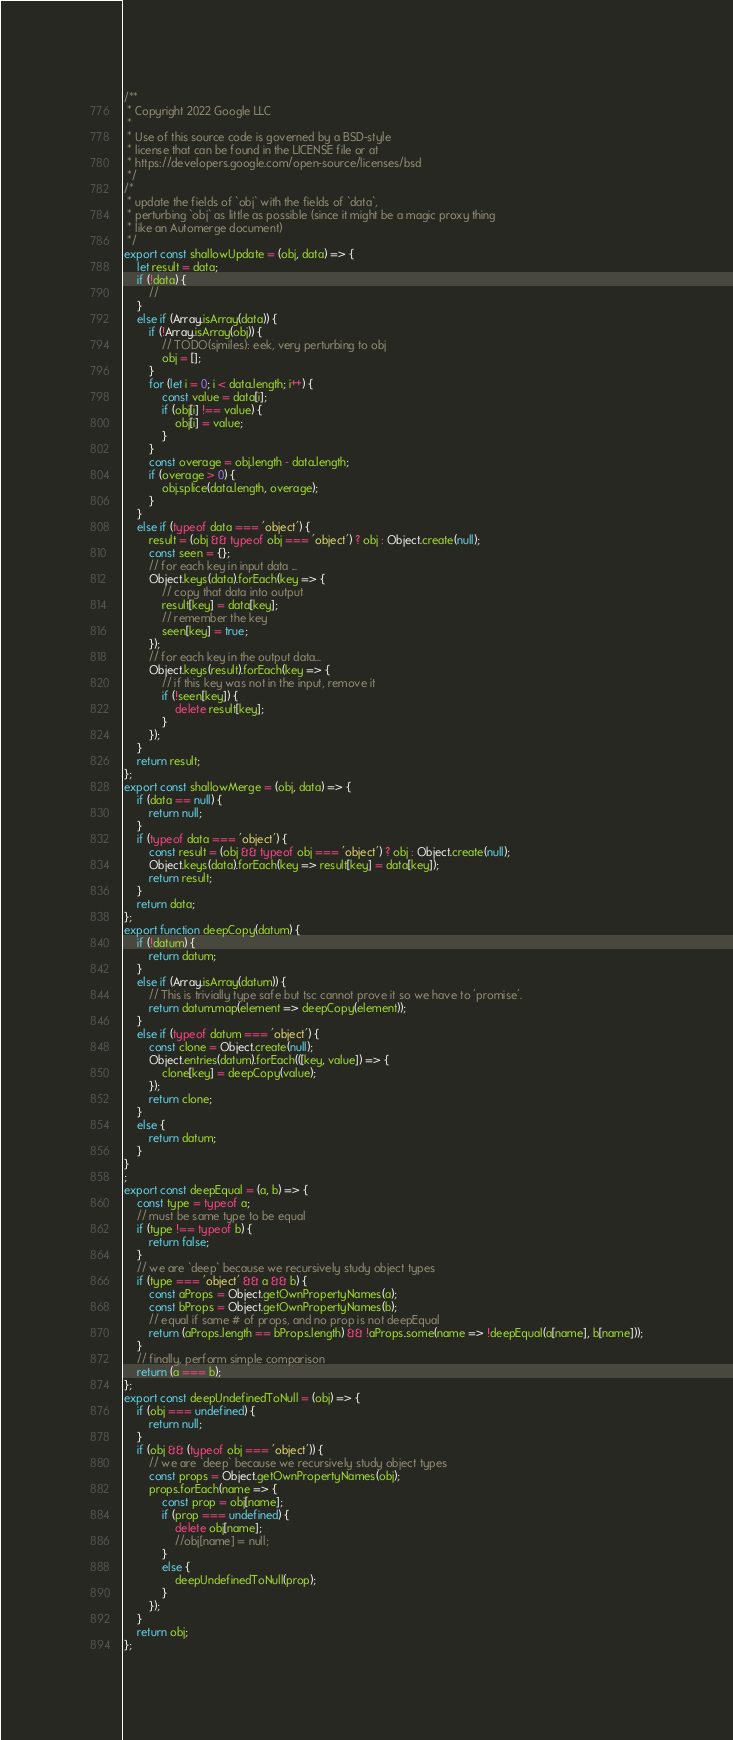Convert code to text. <code><loc_0><loc_0><loc_500><loc_500><_JavaScript_>/**
 * Copyright 2022 Google LLC
 *
 * Use of this source code is governed by a BSD-style
 * license that can be found in the LICENSE file or at
 * https://developers.google.com/open-source/licenses/bsd
 */
/*
 * update the fields of `obj` with the fields of `data`,
 * perturbing `obj` as little as possible (since it might be a magic proxy thing
 * like an Automerge document)
 */
export const shallowUpdate = (obj, data) => {
    let result = data;
    if (!data) {
        //
    }
    else if (Array.isArray(data)) {
        if (!Array.isArray(obj)) {
            // TODO(sjmiles): eek, very perturbing to obj
            obj = [];
        }
        for (let i = 0; i < data.length; i++) {
            const value = data[i];
            if (obj[i] !== value) {
                obj[i] = value;
            }
        }
        const overage = obj.length - data.length;
        if (overage > 0) {
            obj.splice(data.length, overage);
        }
    }
    else if (typeof data === 'object') {
        result = (obj && typeof obj === 'object') ? obj : Object.create(null);
        const seen = {};
        // for each key in input data ...
        Object.keys(data).forEach(key => {
            // copy that data into output
            result[key] = data[key];
            // remember the key
            seen[key] = true;
        });
        // for each key in the output data...
        Object.keys(result).forEach(key => {
            // if this key was not in the input, remove it
            if (!seen[key]) {
                delete result[key];
            }
        });
    }
    return result;
};
export const shallowMerge = (obj, data) => {
    if (data == null) {
        return null;
    }
    if (typeof data === 'object') {
        const result = (obj && typeof obj === 'object') ? obj : Object.create(null);
        Object.keys(data).forEach(key => result[key] = data[key]);
        return result;
    }
    return data;
};
export function deepCopy(datum) {
    if (!datum) {
        return datum;
    }
    else if (Array.isArray(datum)) {
        // This is trivially type safe but tsc cannot prove it so we have to 'promise'.
        return datum.map(element => deepCopy(element));
    }
    else if (typeof datum === 'object') {
        const clone = Object.create(null);
        Object.entries(datum).forEach(([key, value]) => {
            clone[key] = deepCopy(value);
        });
        return clone;
    }
    else {
        return datum;
    }
}
;
export const deepEqual = (a, b) => {
    const type = typeof a;
    // must be same type to be equal
    if (type !== typeof b) {
        return false;
    }
    // we are `deep` because we recursively study object types
    if (type === 'object' && a && b) {
        const aProps = Object.getOwnPropertyNames(a);
        const bProps = Object.getOwnPropertyNames(b);
        // equal if same # of props, and no prop is not deepEqual
        return (aProps.length == bProps.length) && !aProps.some(name => !deepEqual(a[name], b[name]));
    }
    // finally, perform simple comparison
    return (a === b);
};
export const deepUndefinedToNull = (obj) => {
    if (obj === undefined) {
        return null;
    }
    if (obj && (typeof obj === 'object')) {
        // we are `deep` because we recursively study object types
        const props = Object.getOwnPropertyNames(obj);
        props.forEach(name => {
            const prop = obj[name];
            if (prop === undefined) {
                delete obj[name];
                //obj[name] = null;
            }
            else {
                deepUndefinedToNull(prop);
            }
        });
    }
    return obj;
};
</code> 